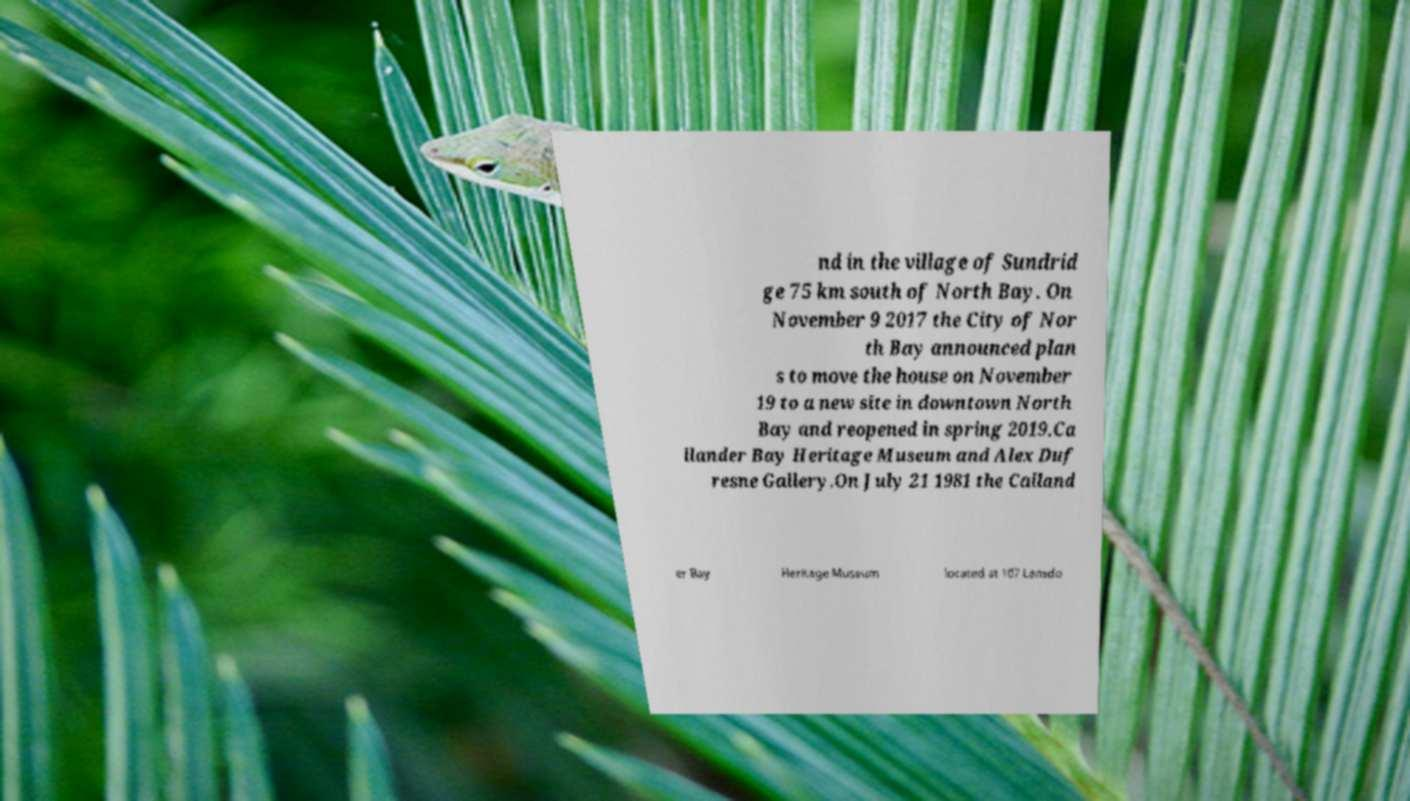Could you assist in decoding the text presented in this image and type it out clearly? nd in the village of Sundrid ge 75 km south of North Bay. On November 9 2017 the City of Nor th Bay announced plan s to move the house on November 19 to a new site in downtown North Bay and reopened in spring 2019.Ca llander Bay Heritage Museum and Alex Duf resne Gallery.On July 21 1981 the Calland er Bay Heritage Museum located at 107 Lansdo 